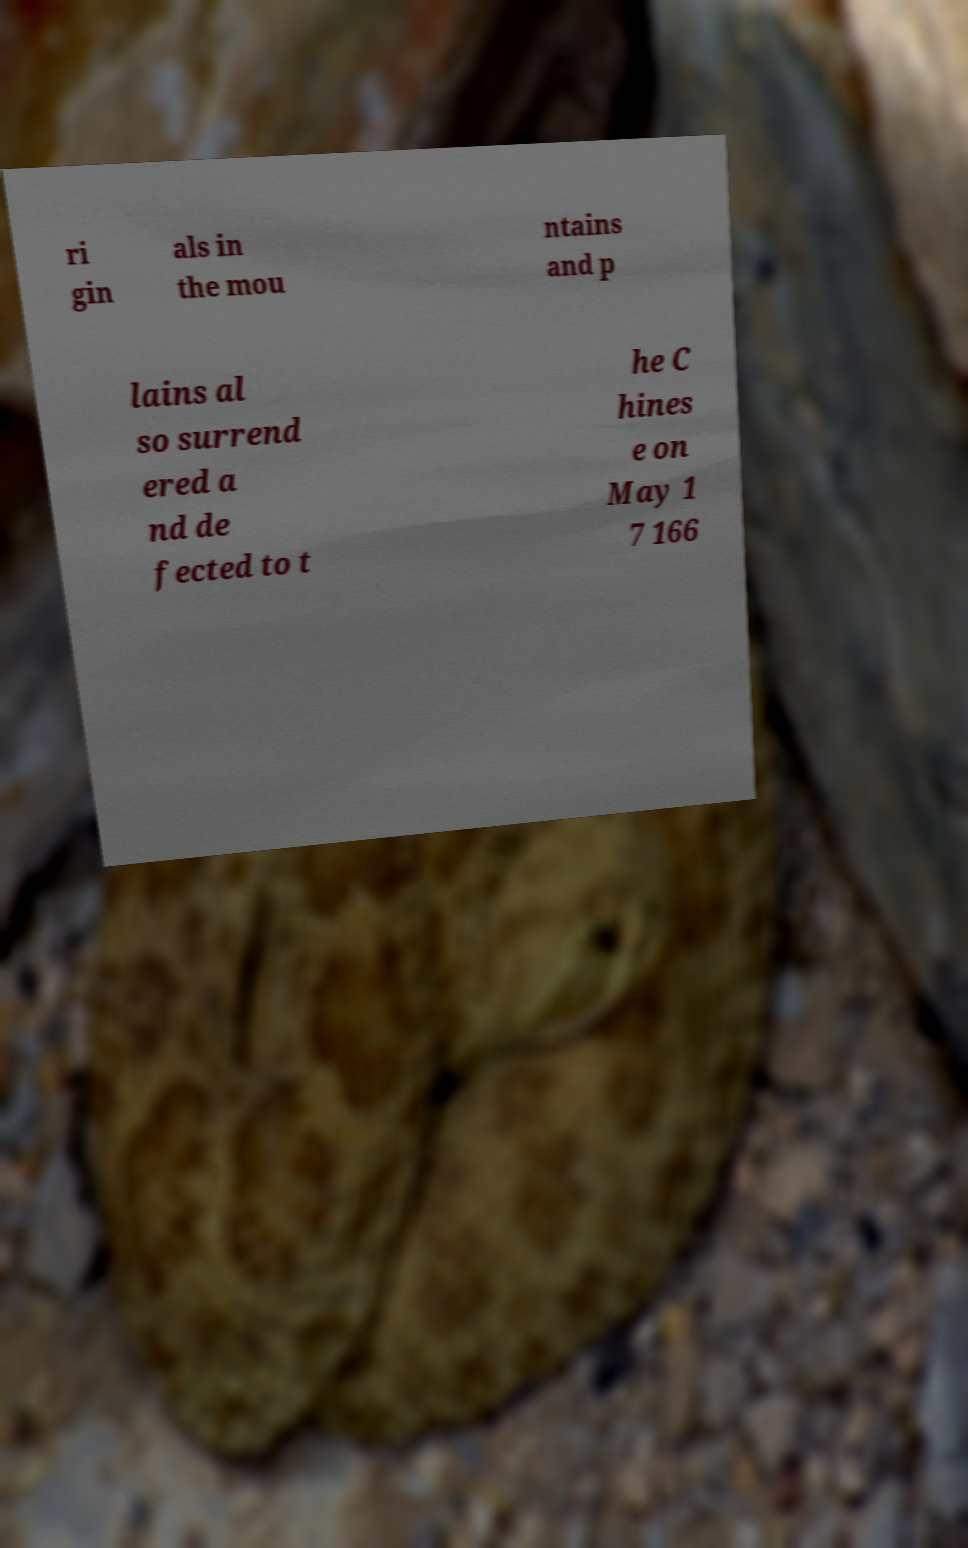Please read and relay the text visible in this image. What does it say? ri gin als in the mou ntains and p lains al so surrend ered a nd de fected to t he C hines e on May 1 7 166 